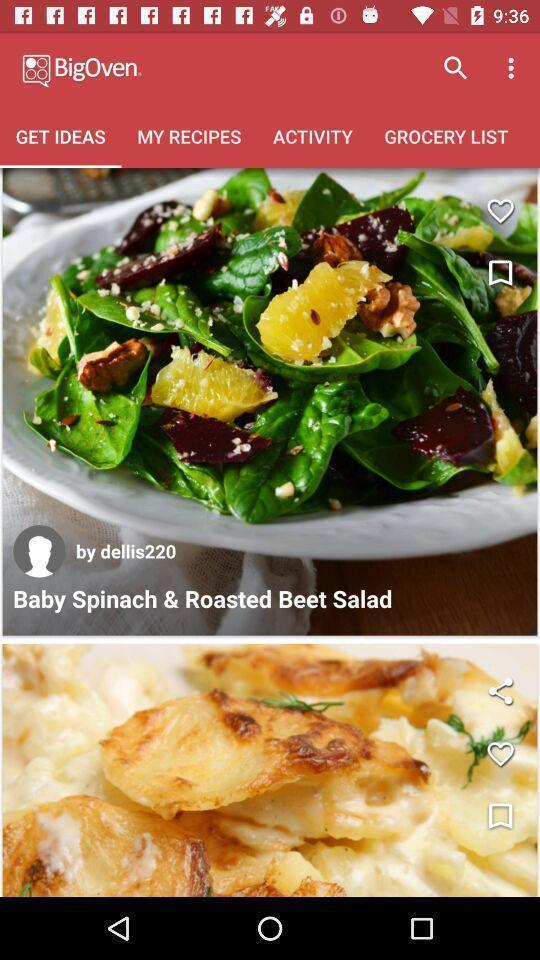Describe the visual elements of this screenshot. Screen shows to get ideas. 